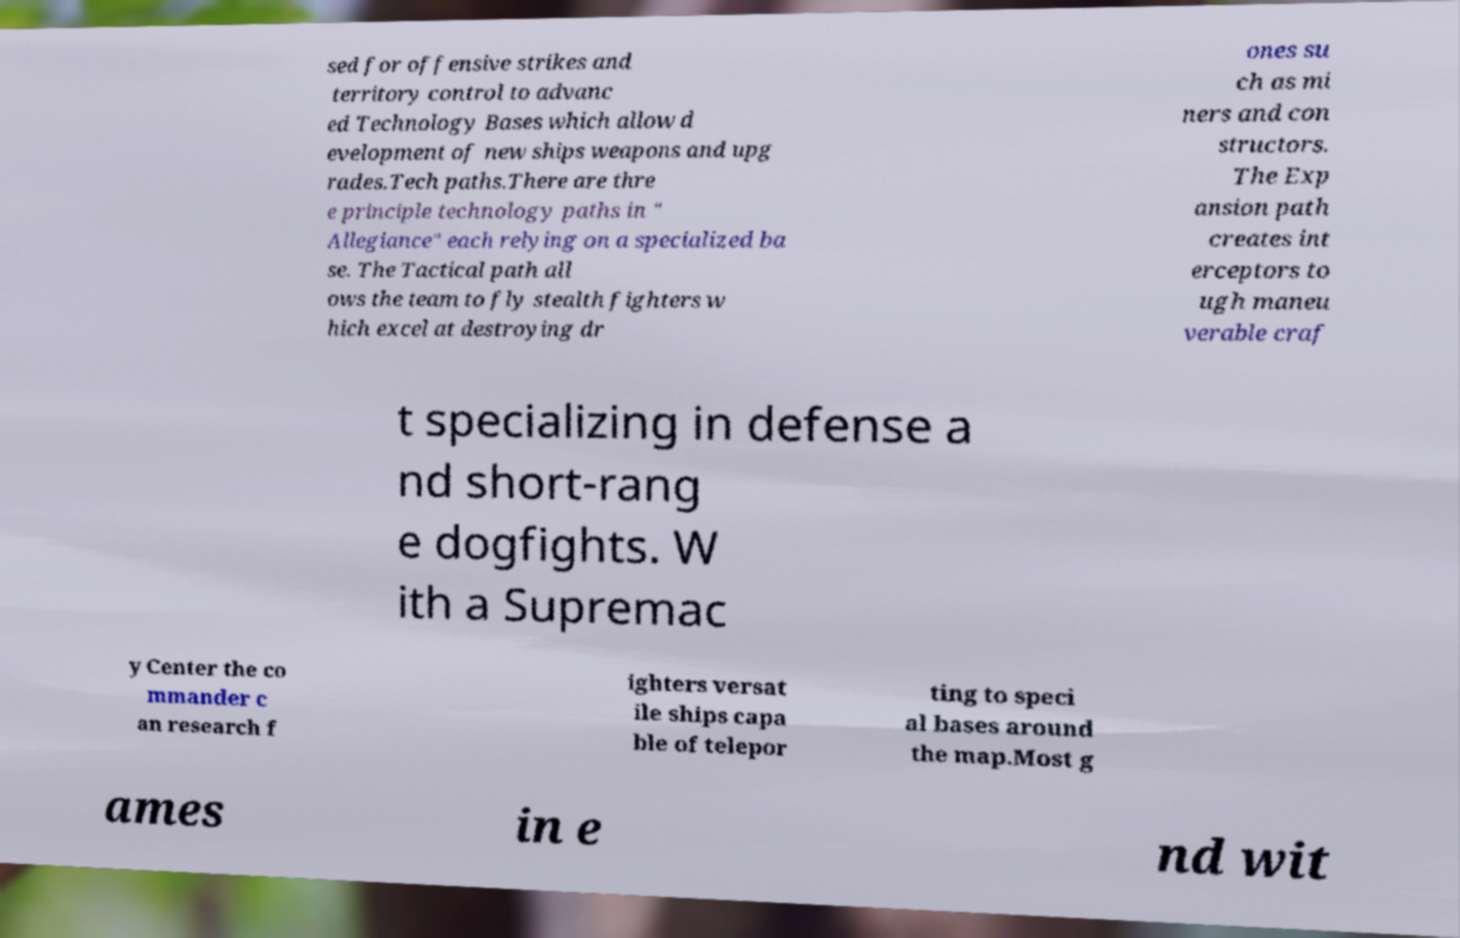I need the written content from this picture converted into text. Can you do that? sed for offensive strikes and territory control to advanc ed Technology Bases which allow d evelopment of new ships weapons and upg rades.Tech paths.There are thre e principle technology paths in " Allegiance" each relying on a specialized ba se. The Tactical path all ows the team to fly stealth fighters w hich excel at destroying dr ones su ch as mi ners and con structors. The Exp ansion path creates int erceptors to ugh maneu verable craf t specializing in defense a nd short-rang e dogfights. W ith a Supremac y Center the co mmander c an research f ighters versat ile ships capa ble of telepor ting to speci al bases around the map.Most g ames in e nd wit 